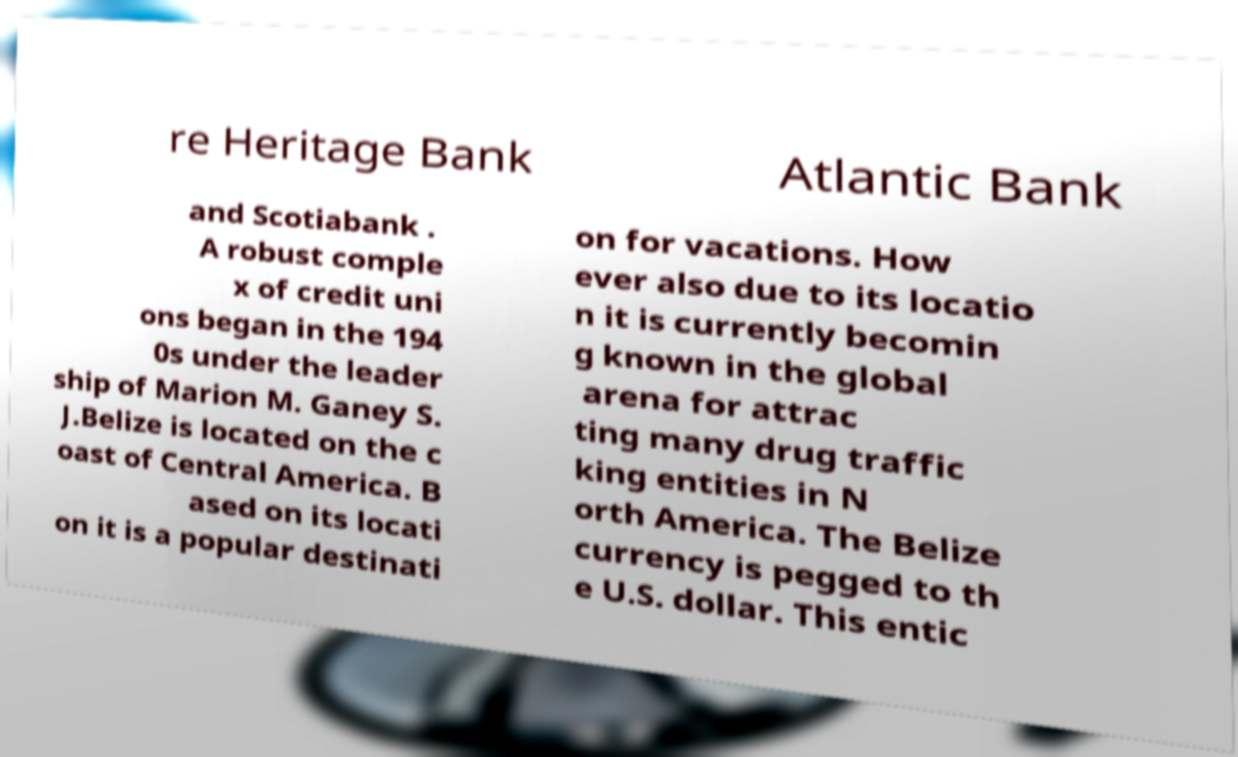Can you read and provide the text displayed in the image?This photo seems to have some interesting text. Can you extract and type it out for me? re Heritage Bank Atlantic Bank and Scotiabank . A robust comple x of credit uni ons began in the 194 0s under the leader ship of Marion M. Ganey S. J.Belize is located on the c oast of Central America. B ased on its locati on it is a popular destinati on for vacations. How ever also due to its locatio n it is currently becomin g known in the global arena for attrac ting many drug traffic king entities in N orth America. The Belize currency is pegged to th e U.S. dollar. This entic 